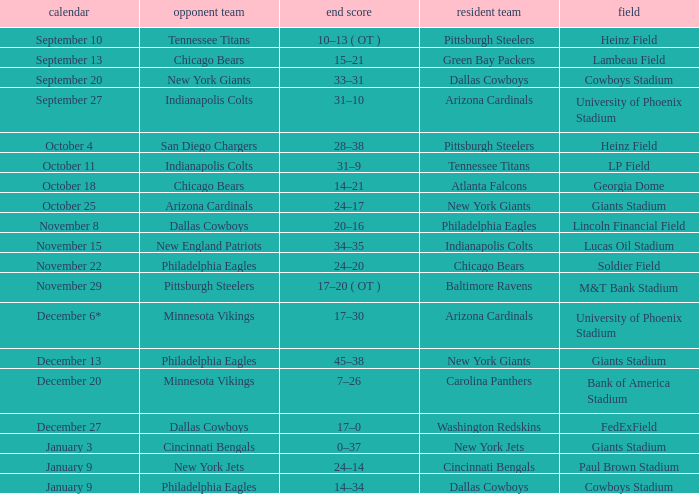Tell me the final score for january 9 for cincinnati bengals 24–14. 